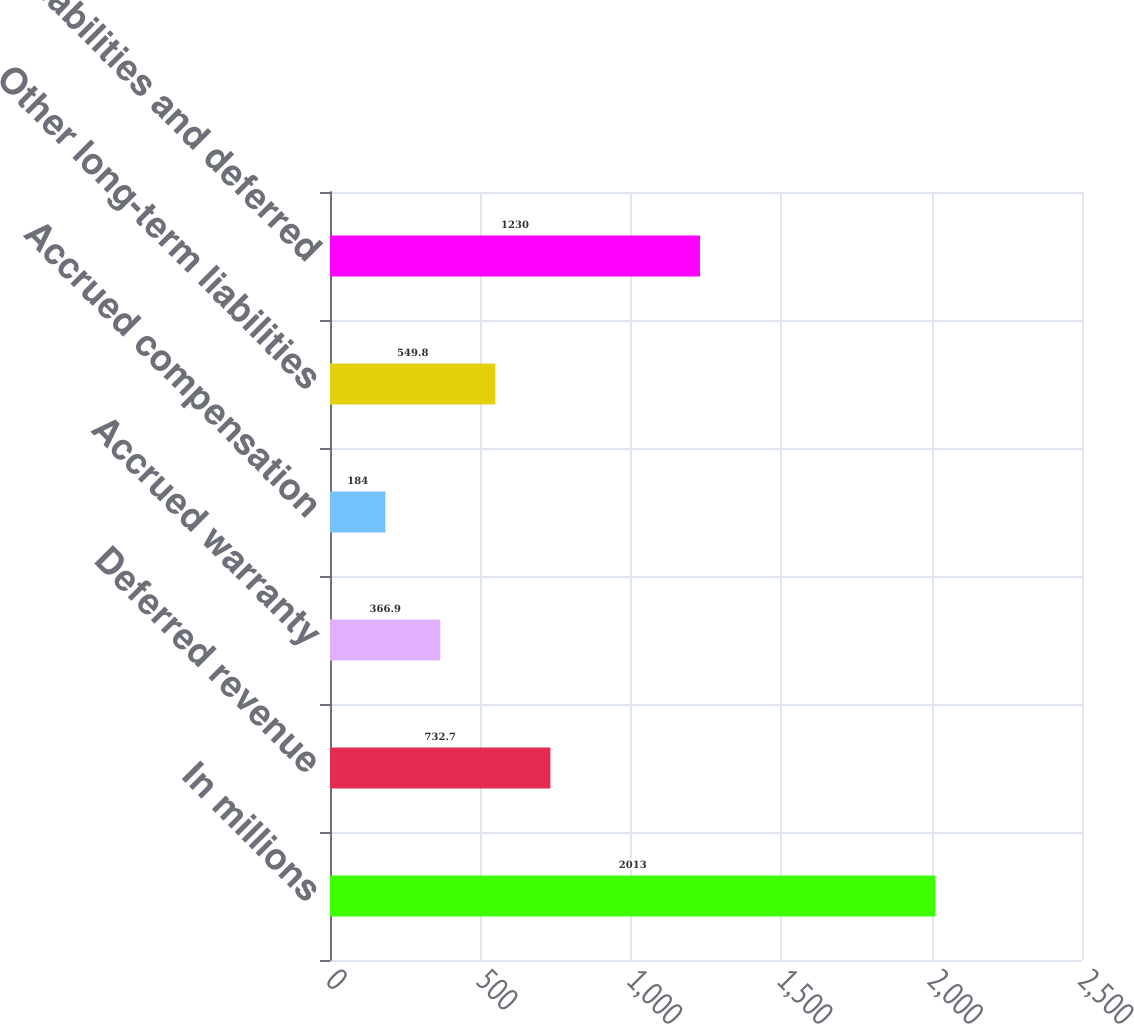Convert chart to OTSL. <chart><loc_0><loc_0><loc_500><loc_500><bar_chart><fcel>In millions<fcel>Deferred revenue<fcel>Accrued warranty<fcel>Accrued compensation<fcel>Other long-term liabilities<fcel>Other liabilities and deferred<nl><fcel>2013<fcel>732.7<fcel>366.9<fcel>184<fcel>549.8<fcel>1230<nl></chart> 